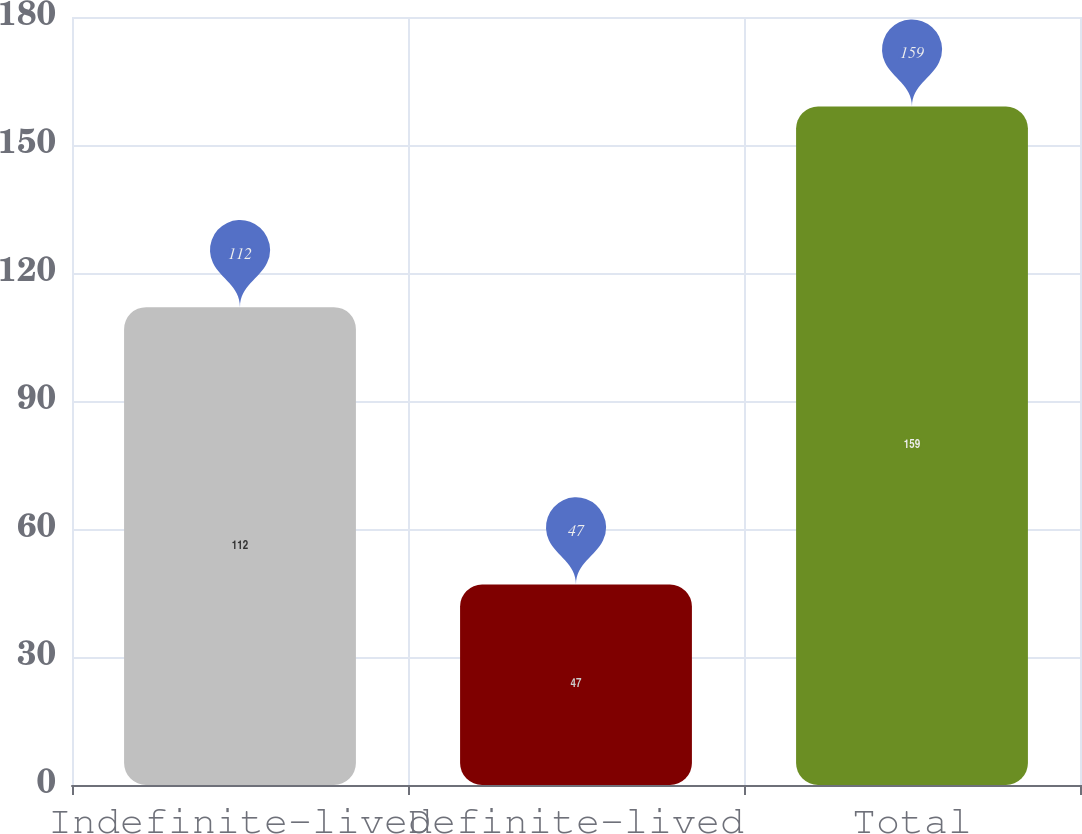Convert chart to OTSL. <chart><loc_0><loc_0><loc_500><loc_500><bar_chart><fcel>Indefinite-lived<fcel>Definite-lived<fcel>Total<nl><fcel>112<fcel>47<fcel>159<nl></chart> 